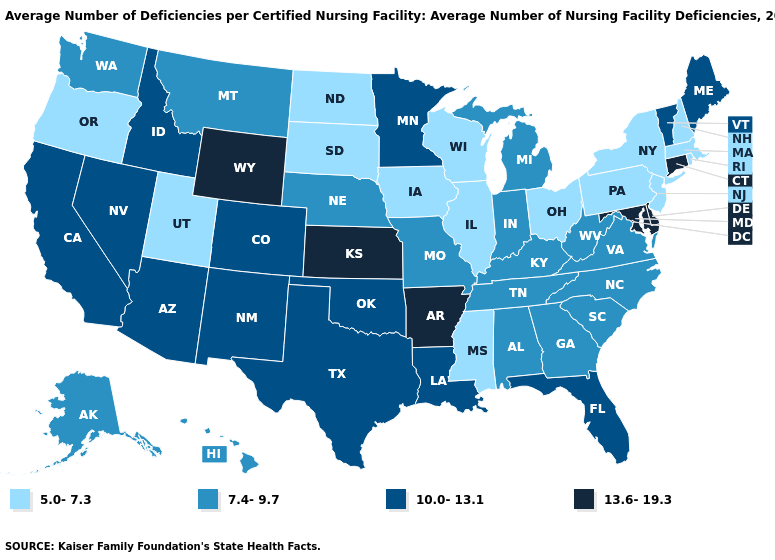What is the value of Arizona?
Concise answer only. 10.0-13.1. Does Utah have the lowest value in the West?
Give a very brief answer. Yes. Name the states that have a value in the range 10.0-13.1?
Write a very short answer. Arizona, California, Colorado, Florida, Idaho, Louisiana, Maine, Minnesota, Nevada, New Mexico, Oklahoma, Texas, Vermont. Name the states that have a value in the range 5.0-7.3?
Keep it brief. Illinois, Iowa, Massachusetts, Mississippi, New Hampshire, New Jersey, New York, North Dakota, Ohio, Oregon, Pennsylvania, Rhode Island, South Dakota, Utah, Wisconsin. Is the legend a continuous bar?
Answer briefly. No. What is the value of Nebraska?
Be succinct. 7.4-9.7. Does North Carolina have the same value as Indiana?
Short answer required. Yes. What is the highest value in states that border Missouri?
Concise answer only. 13.6-19.3. What is the value of West Virginia?
Concise answer only. 7.4-9.7. Which states have the lowest value in the Northeast?
Quick response, please. Massachusetts, New Hampshire, New Jersey, New York, Pennsylvania, Rhode Island. Does Rhode Island have the lowest value in the Northeast?
Concise answer only. Yes. Does Virginia have the highest value in the USA?
Answer briefly. No. What is the lowest value in the South?
Quick response, please. 5.0-7.3. What is the lowest value in the South?
Be succinct. 5.0-7.3. Name the states that have a value in the range 10.0-13.1?
Answer briefly. Arizona, California, Colorado, Florida, Idaho, Louisiana, Maine, Minnesota, Nevada, New Mexico, Oklahoma, Texas, Vermont. 